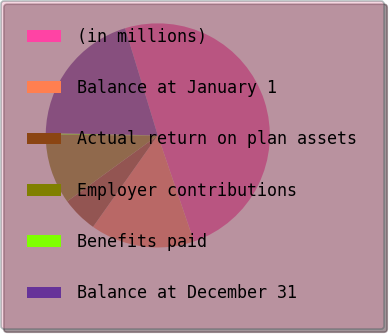Convert chart. <chart><loc_0><loc_0><loc_500><loc_500><pie_chart><fcel>(in millions)<fcel>Balance at January 1<fcel>Actual return on plan assets<fcel>Employer contributions<fcel>Benefits paid<fcel>Balance at December 31<nl><fcel>49.48%<fcel>15.03%<fcel>5.18%<fcel>10.1%<fcel>0.26%<fcel>19.95%<nl></chart> 